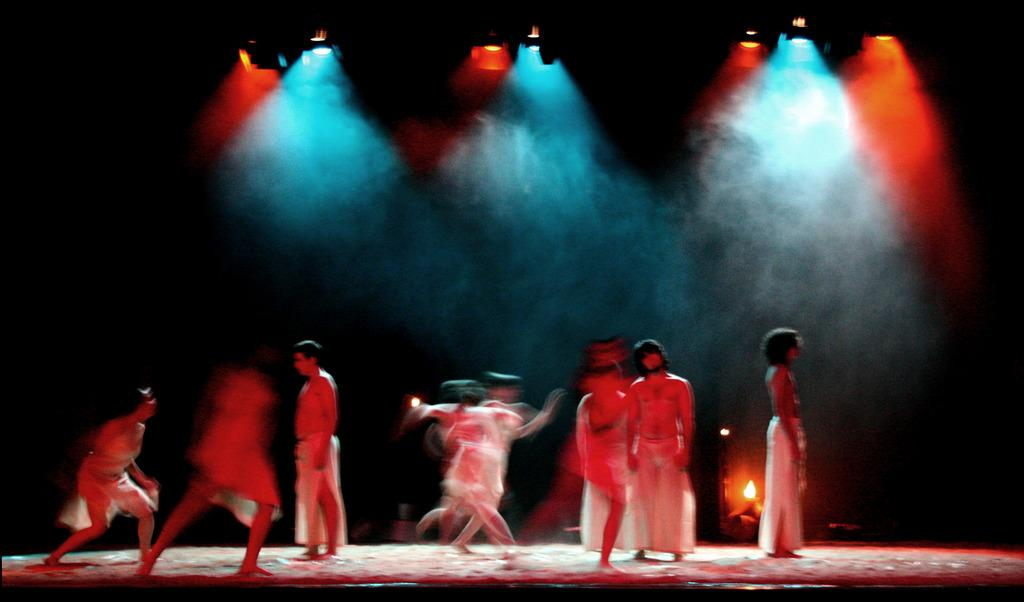What is happening on the stage in the image? There are people on the stage in the image. What can be seen in the background of the stage? There is fire in the background of the image. What is located at the top of the image? There are lights on the top of the image. What is the plot of the play being performed on the stage in the image? There is no information about a play or its plot in the image. How do the people on the stage move around in the image? The image is a still photograph, so the people on the stage are not moving. 